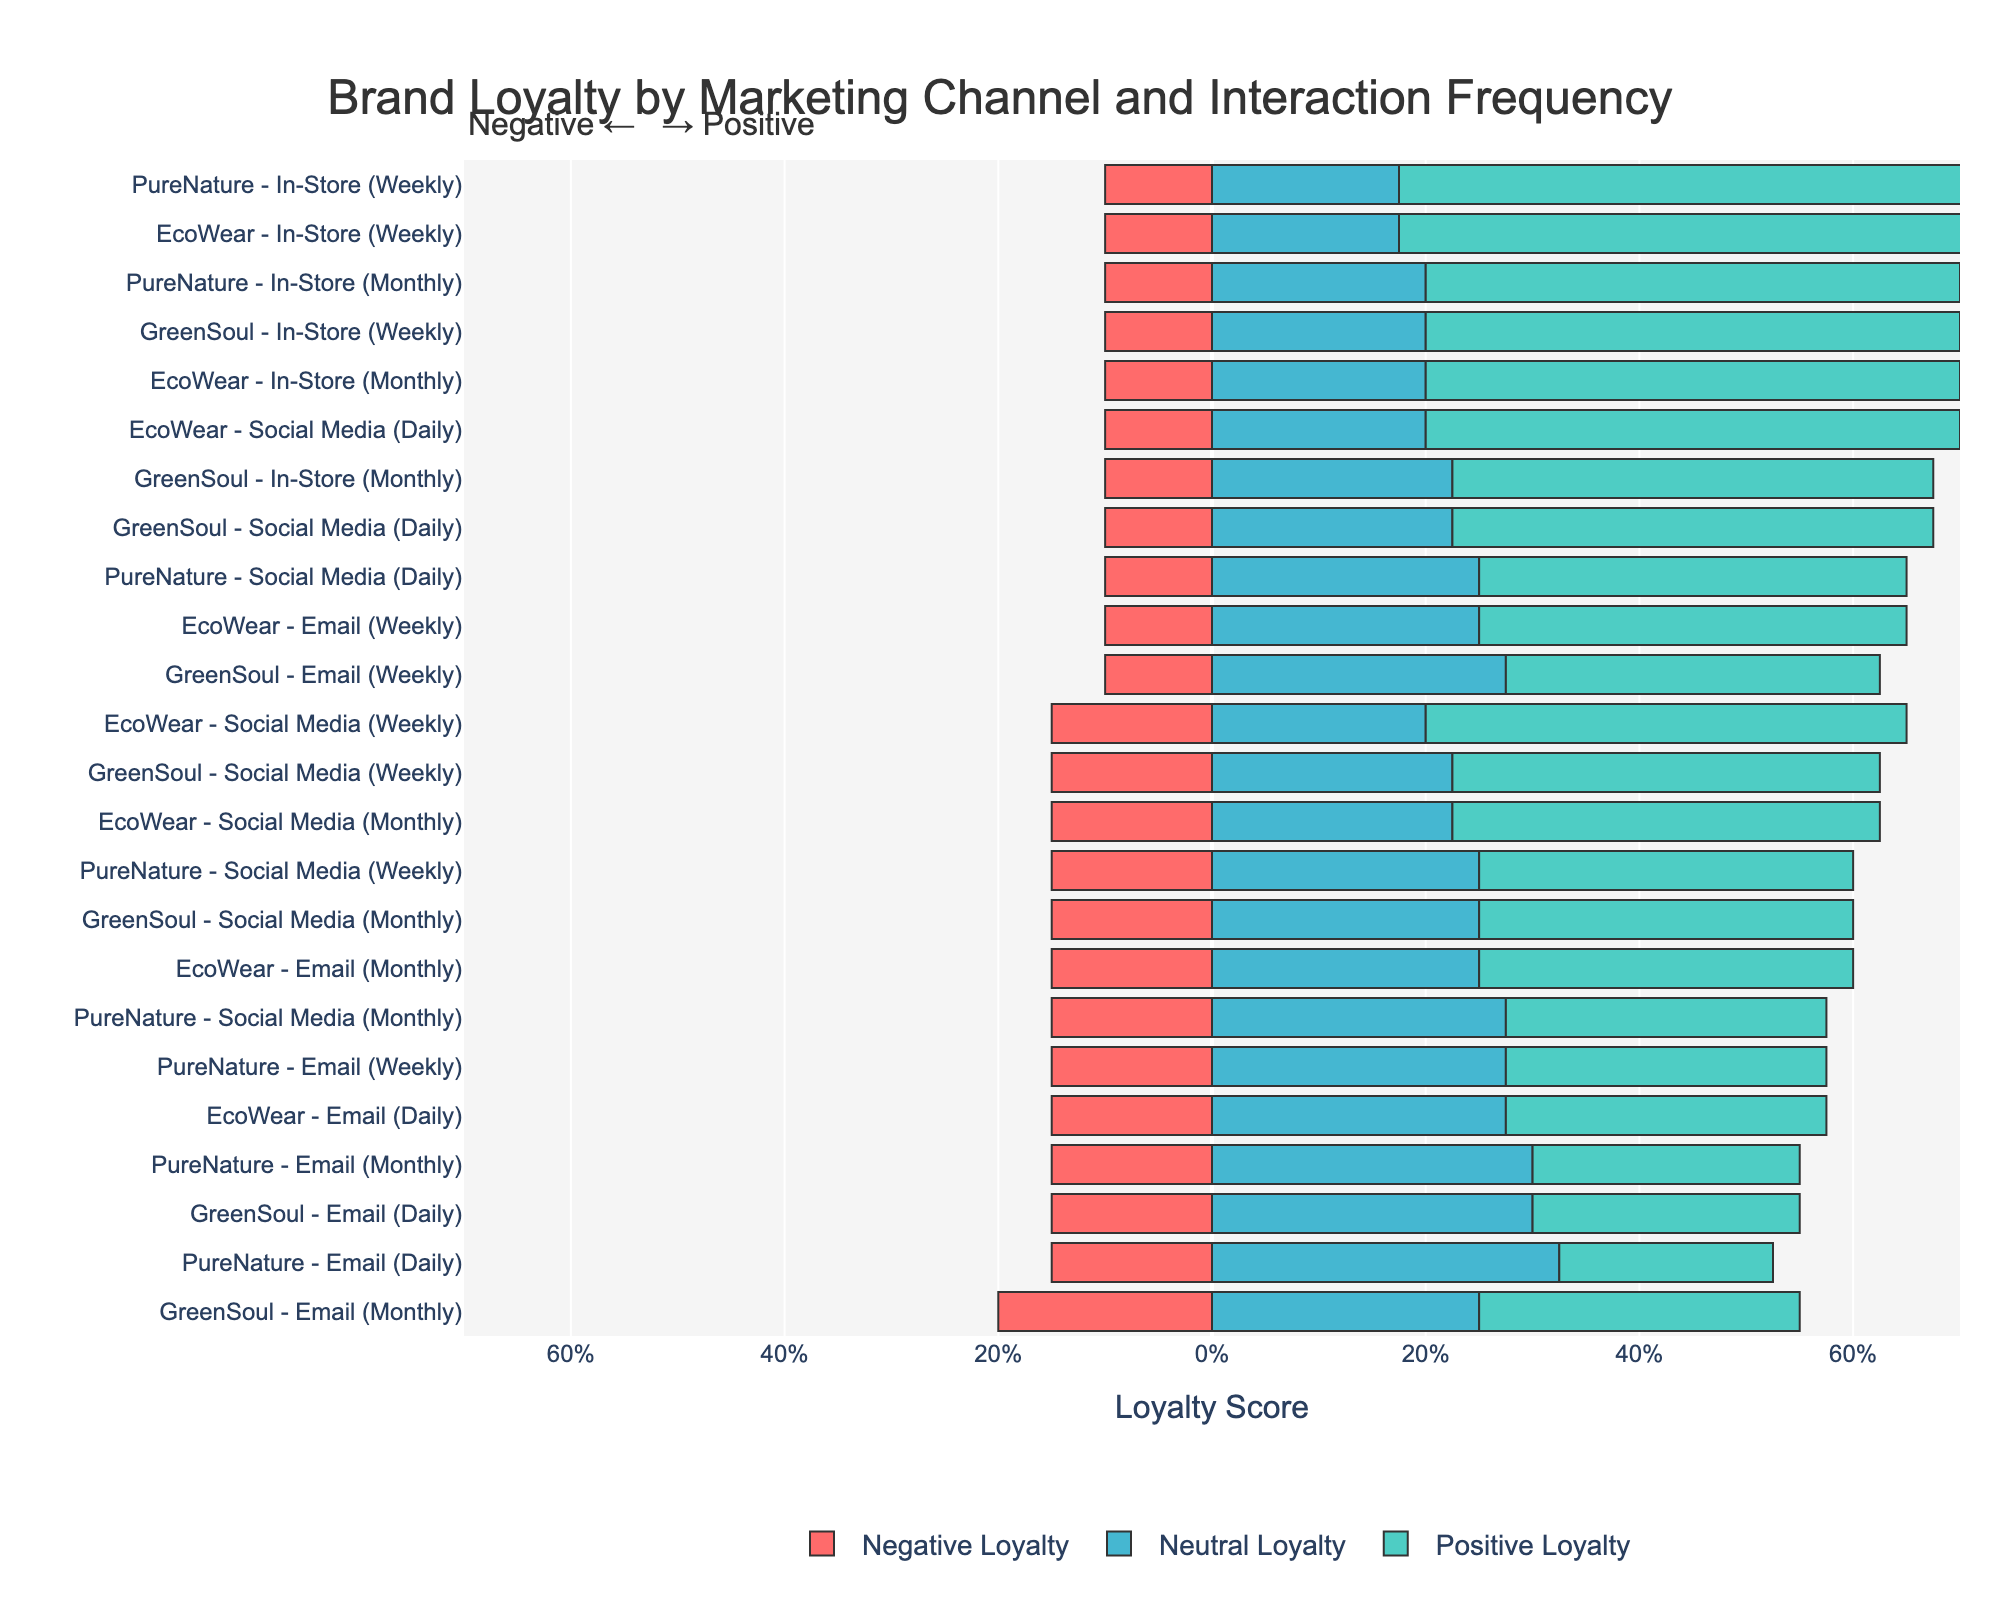What is the total Positive Loyalty score for GreenSoul on Social Media across all frequencies? First, identify the Positive Loyalty scores for GreenSoul on Social Media: Daily (45), Weekly (40), Monthly (35). Then, sum these values: 45 + 40 + 35 = 120.
Answer: 120 Which brand and marketing channel combination has the highest Negative Loyalty score for daily interactions? Compare the Negative Loyalty scores for daily interactions: EcoWear Email (15), EcoWear Social Media (10), GreenSoul Email (15), GreenSoul Social Media (10), PureNature Email (15), PureNature Social Media (10). The highest score is 15, which is seen in EcoWear Email, GreenSoul Email, and PureNature Email.
Answer: EcoWear Email, GreenSoul Email, PureNature Email Between EcoWear and PureNature, which brand has a higher Positive Loyalty score for weekly Social Media interactions? Compare the Positive Loyalty scores for weekly Social Media interactions: EcoWear (45) and PureNature (35). EcoWear has a higher score.
Answer: EcoWear Which marketing channel has the lowest average Neutral Loyalty score for the brand PureNature? Calculate the average Neutral Loyalty score for each channel for PureNature:
Email: (65 + 55 + 60) / 3 = 60
Social Media: (50 + 50 + 55) / 3 = 51.67
In-Store: (35 + 40) / 2 = 37.5
The lowest average is for the In-Store channel.
Answer: In-Store For EcoWear, which interaction frequency type across all marketing channels shows the most balanced triple distribution (closest values for Positive, Neutral, and Negative)? For each interaction frequency, compare the gaps among Positive, Neutral, and Negative Loyalty scores:
Email Daily: 30, 55, 15 (gap 25, 15)
Email Weekly: 40, 50, 10 (gap 10, 40)
Email Monthly: 35, 50, 15 (gap 15, 35)
Social Media Daily: 50, 40, 10 (gap 10, 40)
Social Media Weekly: 45, 40, 15 (gap 5, 25)
Social Media Monthly: 40, 45, 15 (gap 5, 25)
In-Store Weekly: 55, 35, 10 (gap 20, 45)
In-Store Monthly: 50, 40, 10 (gap 10, 40)
The most balanced distribution is for Social Media Weekly and Monthly where the gaps between Positive, Neutral, and Negative scores are smaller compared to others.
Answer: Social Media Weekly, Social Media Monthly Which brand shows the highest Positive Loyalty score for weekly In-Store interactions? Compare the Positive Loyalty scores for weekly In-Store interactions: EcoWear (55), GreenSoul (50), PureNature (55). Both EcoWear and PureNature have the highest score of 55.
Answer: EcoWear, PureNature What's the difference in total Positive Loyalty scores between EcoWear and PureNature for email interactions? Calculate the total Positive Loyalty score for email interactions for each brand:
EcoWear: 30 + 40 + 35 = 105
PureNature: 20 + 30 + 25 = 75
The difference is 105 - 75 = 30.
Answer: 30 Is there any brand with a higher Positive Loyalty on Social Media compared to In-Store for the same interaction frequency? Compare the Positive Loyalty scores for Social Media and In-Store for each frequency per brand:
EcoWear Weekly: Social Media (45) vs In-Store (55)
GreenSoul Weekly: Social Media (40) vs In-Store (50)
PureNature Weekly: Social Media (35) vs In-Store (55)
So, no brand has a higher Positive Loyalty on Social Media compared to In-Store for the same frequency.
Answer: No 